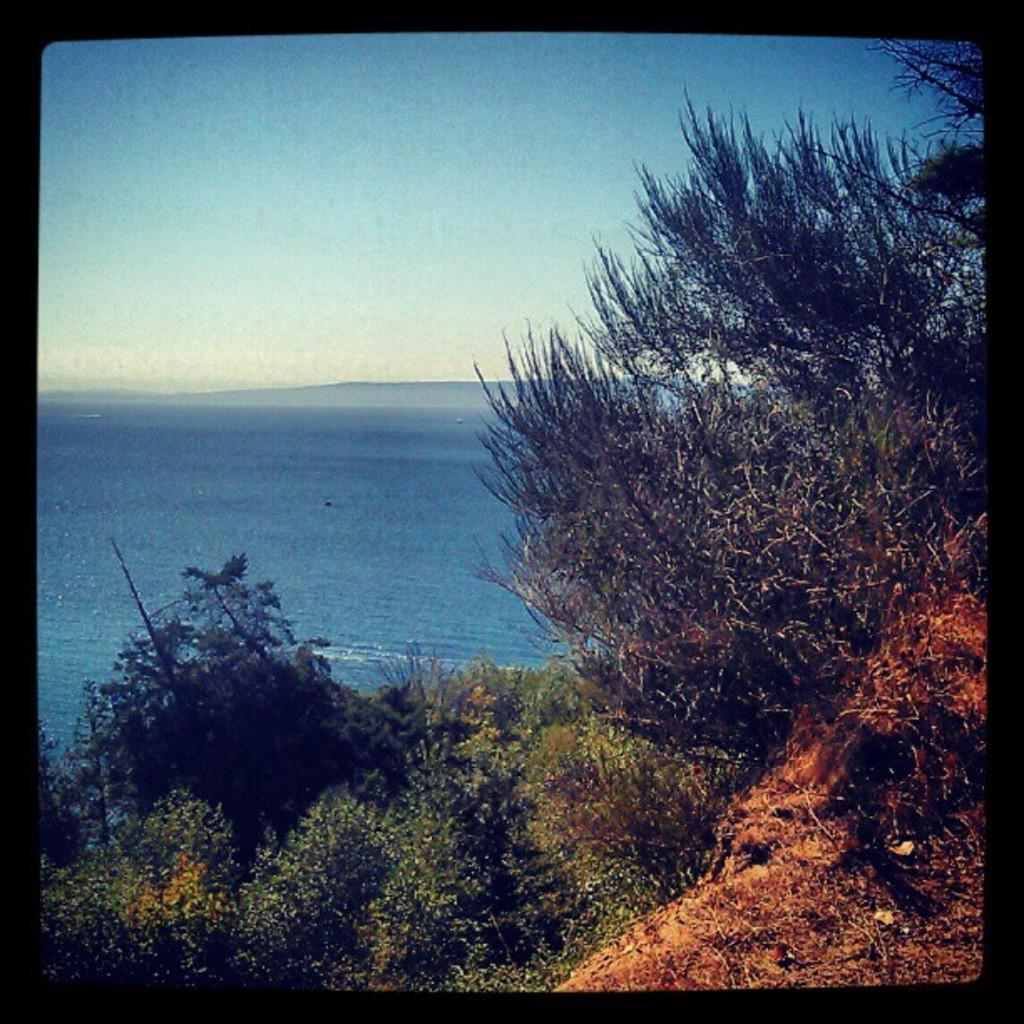Where was the image taken? The image was taken outdoors. What can be seen at the top of the image? The sky is visible at the top of the image. What is the main feature in the middle of the image? There is sea in the middle of the image. What type of vegetation is present at the bottom of the image? There are plants on the ground at the bottom of the image. How many faces can be seen in the image? There are no faces present in the image. What type of worm is crawling on the plants at the bottom of the image? There are no worms present in the image; only plants can be seen at the bottom of the image. 